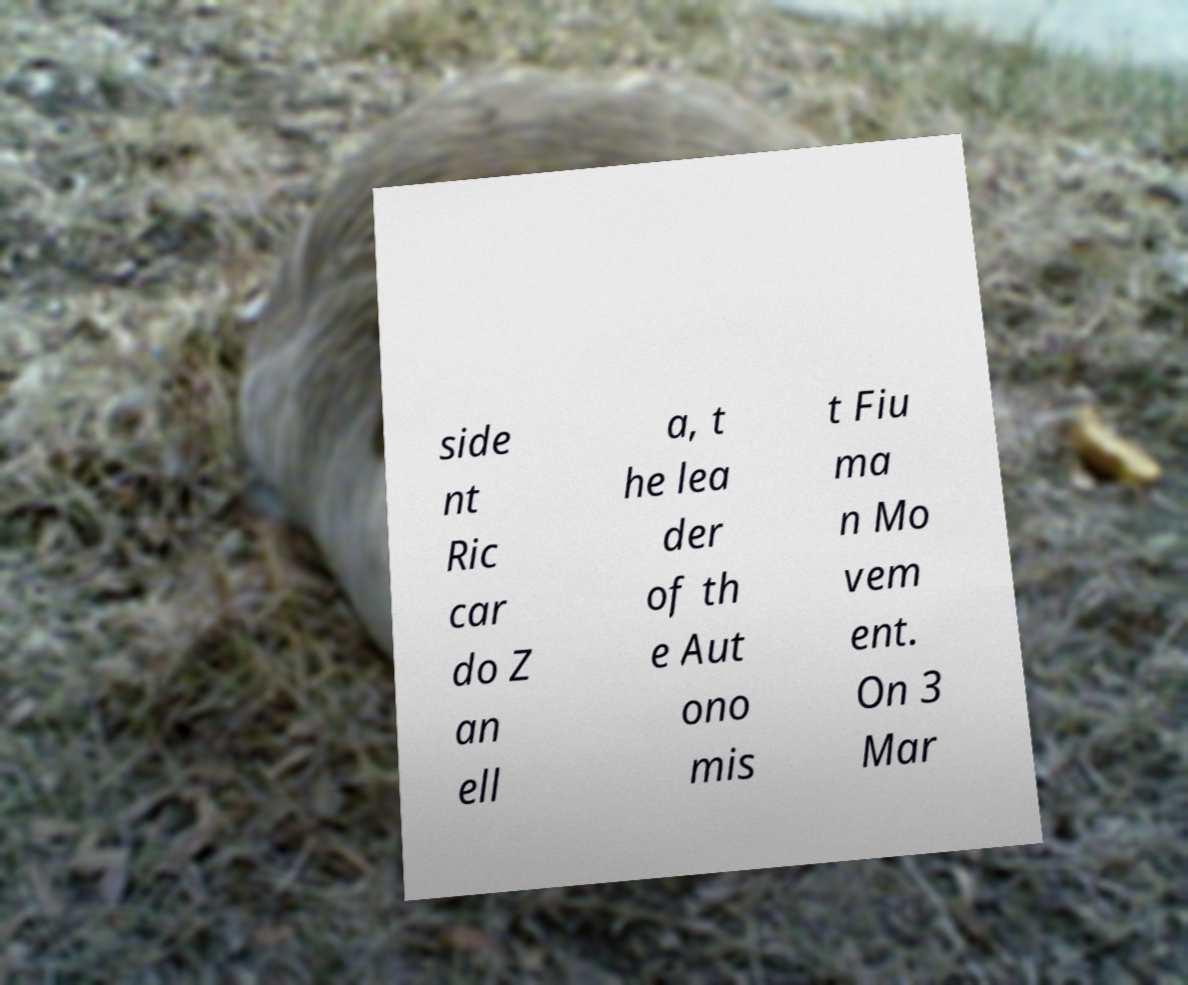There's text embedded in this image that I need extracted. Can you transcribe it verbatim? side nt Ric car do Z an ell a, t he lea der of th e Aut ono mis t Fiu ma n Mo vem ent. On 3 Mar 